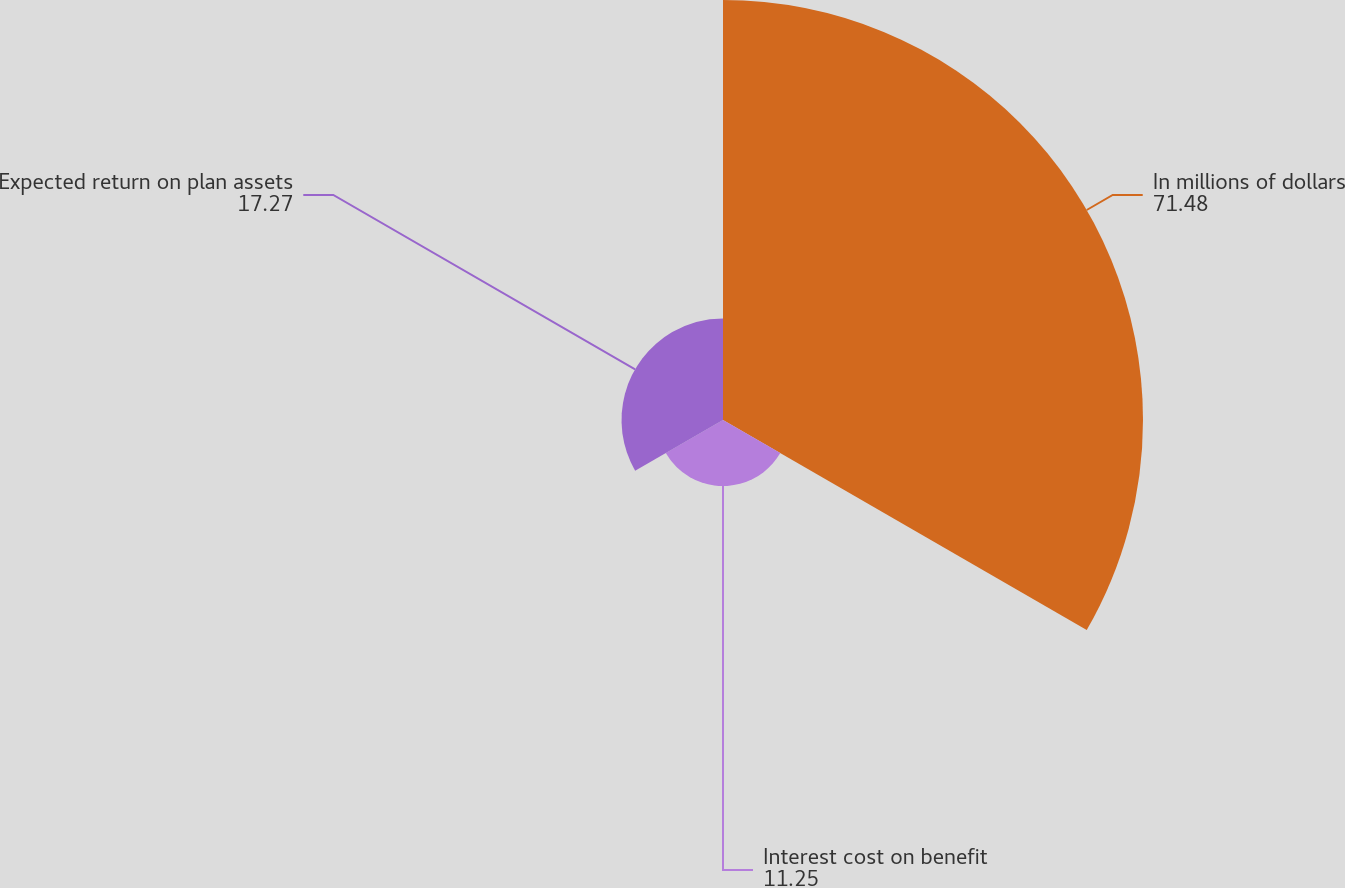Convert chart to OTSL. <chart><loc_0><loc_0><loc_500><loc_500><pie_chart><fcel>In millions of dollars<fcel>Interest cost on benefit<fcel>Expected return on plan assets<nl><fcel>71.48%<fcel>11.25%<fcel>17.27%<nl></chart> 